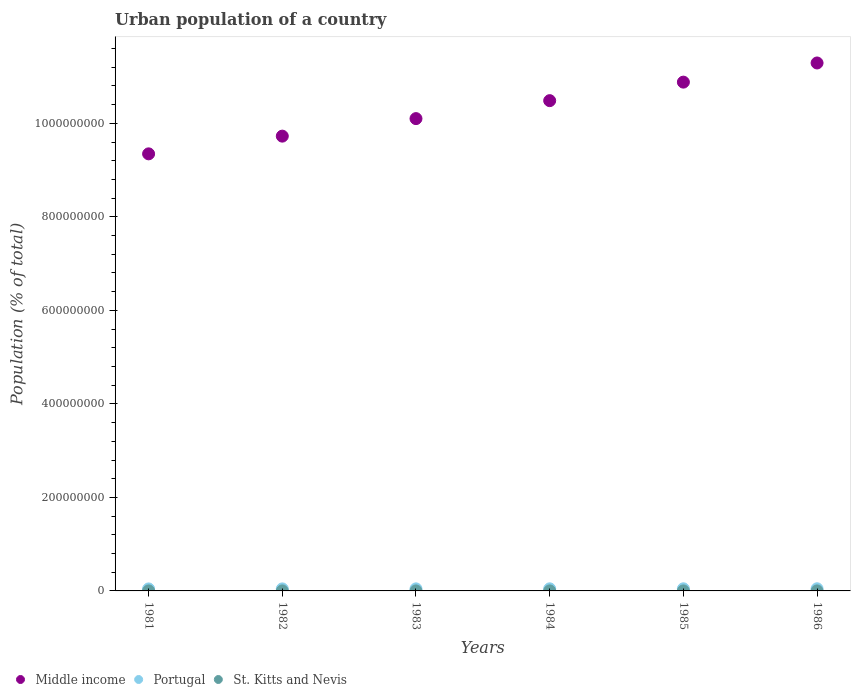What is the urban population in Portugal in 1984?
Give a very brief answer. 4.48e+06. Across all years, what is the maximum urban population in Portugal?
Provide a succinct answer. 4.60e+06. Across all years, what is the minimum urban population in St. Kitts and Nevis?
Offer a terse response. 1.46e+04. What is the total urban population in Middle income in the graph?
Offer a very short reply. 6.18e+09. What is the difference between the urban population in Portugal in 1983 and that in 1986?
Give a very brief answer. -1.90e+05. What is the difference between the urban population in Middle income in 1984 and the urban population in St. Kitts and Nevis in 1982?
Offer a terse response. 1.05e+09. What is the average urban population in St. Kitts and Nevis per year?
Your response must be concise. 1.50e+04. In the year 1984, what is the difference between the urban population in St. Kitts and Nevis and urban population in Middle income?
Your answer should be very brief. -1.05e+09. In how many years, is the urban population in St. Kitts and Nevis greater than 40000000 %?
Your answer should be compact. 0. What is the ratio of the urban population in Portugal in 1983 to that in 1986?
Your answer should be very brief. 0.96. Is the urban population in Portugal in 1985 less than that in 1986?
Give a very brief answer. Yes. What is the difference between the highest and the second highest urban population in Middle income?
Offer a terse response. 4.10e+07. What is the difference between the highest and the lowest urban population in St. Kitts and Nevis?
Offer a terse response. 724. In how many years, is the urban population in Middle income greater than the average urban population in Middle income taken over all years?
Offer a terse response. 3. Does the urban population in Middle income monotonically increase over the years?
Your response must be concise. Yes. Is the urban population in St. Kitts and Nevis strictly greater than the urban population in Middle income over the years?
Provide a short and direct response. No. Is the urban population in Middle income strictly less than the urban population in St. Kitts and Nevis over the years?
Keep it short and to the point. No. How many dotlines are there?
Provide a succinct answer. 3. What is the difference between two consecutive major ticks on the Y-axis?
Keep it short and to the point. 2.00e+08. Does the graph contain grids?
Your answer should be very brief. No. Where does the legend appear in the graph?
Provide a succinct answer. Bottom left. What is the title of the graph?
Provide a succinct answer. Urban population of a country. What is the label or title of the Y-axis?
Your response must be concise. Population (% of total). What is the Population (% of total) in Middle income in 1981?
Your answer should be very brief. 9.35e+08. What is the Population (% of total) in Portugal in 1981?
Offer a terse response. 4.26e+06. What is the Population (% of total) in St. Kitts and Nevis in 1981?
Offer a terse response. 1.54e+04. What is the Population (% of total) in Middle income in 1982?
Keep it short and to the point. 9.73e+08. What is the Population (% of total) of Portugal in 1982?
Make the answer very short. 4.34e+06. What is the Population (% of total) in St. Kitts and Nevis in 1982?
Offer a terse response. 1.52e+04. What is the Population (% of total) of Middle income in 1983?
Give a very brief answer. 1.01e+09. What is the Population (% of total) of Portugal in 1983?
Keep it short and to the point. 4.41e+06. What is the Population (% of total) in St. Kitts and Nevis in 1983?
Offer a very short reply. 1.51e+04. What is the Population (% of total) of Middle income in 1984?
Keep it short and to the point. 1.05e+09. What is the Population (% of total) of Portugal in 1984?
Give a very brief answer. 4.48e+06. What is the Population (% of total) of St. Kitts and Nevis in 1984?
Your response must be concise. 1.50e+04. What is the Population (% of total) in Middle income in 1985?
Give a very brief answer. 1.09e+09. What is the Population (% of total) of Portugal in 1985?
Your response must be concise. 4.54e+06. What is the Population (% of total) in St. Kitts and Nevis in 1985?
Your answer should be compact. 1.48e+04. What is the Population (% of total) of Middle income in 1986?
Provide a short and direct response. 1.13e+09. What is the Population (% of total) in Portugal in 1986?
Offer a very short reply. 4.60e+06. What is the Population (% of total) of St. Kitts and Nevis in 1986?
Your answer should be very brief. 1.46e+04. Across all years, what is the maximum Population (% of total) in Middle income?
Give a very brief answer. 1.13e+09. Across all years, what is the maximum Population (% of total) in Portugal?
Your answer should be very brief. 4.60e+06. Across all years, what is the maximum Population (% of total) of St. Kitts and Nevis?
Your response must be concise. 1.54e+04. Across all years, what is the minimum Population (% of total) in Middle income?
Offer a very short reply. 9.35e+08. Across all years, what is the minimum Population (% of total) of Portugal?
Offer a very short reply. 4.26e+06. Across all years, what is the minimum Population (% of total) of St. Kitts and Nevis?
Your response must be concise. 1.46e+04. What is the total Population (% of total) of Middle income in the graph?
Ensure brevity in your answer.  6.18e+09. What is the total Population (% of total) in Portugal in the graph?
Provide a succinct answer. 2.66e+07. What is the total Population (% of total) in St. Kitts and Nevis in the graph?
Your answer should be compact. 9.01e+04. What is the difference between the Population (% of total) of Middle income in 1981 and that in 1982?
Give a very brief answer. -3.79e+07. What is the difference between the Population (% of total) in Portugal in 1981 and that in 1982?
Offer a terse response. -7.74e+04. What is the difference between the Population (% of total) of St. Kitts and Nevis in 1981 and that in 1982?
Offer a very short reply. 132. What is the difference between the Population (% of total) of Middle income in 1981 and that in 1983?
Provide a short and direct response. -7.53e+07. What is the difference between the Population (% of total) in Portugal in 1981 and that in 1983?
Provide a short and direct response. -1.49e+05. What is the difference between the Population (% of total) in St. Kitts and Nevis in 1981 and that in 1983?
Keep it short and to the point. 266. What is the difference between the Population (% of total) of Middle income in 1981 and that in 1984?
Provide a short and direct response. -1.14e+08. What is the difference between the Population (% of total) in Portugal in 1981 and that in 1984?
Offer a terse response. -2.18e+05. What is the difference between the Population (% of total) in St. Kitts and Nevis in 1981 and that in 1984?
Offer a very short reply. 407. What is the difference between the Population (% of total) of Middle income in 1981 and that in 1985?
Give a very brief answer. -1.53e+08. What is the difference between the Population (% of total) of Portugal in 1981 and that in 1985?
Your answer should be very brief. -2.83e+05. What is the difference between the Population (% of total) of St. Kitts and Nevis in 1981 and that in 1985?
Make the answer very short. 558. What is the difference between the Population (% of total) in Middle income in 1981 and that in 1986?
Your response must be concise. -1.94e+08. What is the difference between the Population (% of total) in Portugal in 1981 and that in 1986?
Offer a terse response. -3.39e+05. What is the difference between the Population (% of total) of St. Kitts and Nevis in 1981 and that in 1986?
Offer a very short reply. 724. What is the difference between the Population (% of total) of Middle income in 1982 and that in 1983?
Give a very brief answer. -3.75e+07. What is the difference between the Population (% of total) of Portugal in 1982 and that in 1983?
Offer a very short reply. -7.18e+04. What is the difference between the Population (% of total) in St. Kitts and Nevis in 1982 and that in 1983?
Offer a terse response. 134. What is the difference between the Population (% of total) in Middle income in 1982 and that in 1984?
Give a very brief answer. -7.59e+07. What is the difference between the Population (% of total) in Portugal in 1982 and that in 1984?
Your answer should be compact. -1.41e+05. What is the difference between the Population (% of total) in St. Kitts and Nevis in 1982 and that in 1984?
Your answer should be very brief. 275. What is the difference between the Population (% of total) in Middle income in 1982 and that in 1985?
Make the answer very short. -1.16e+08. What is the difference between the Population (% of total) in Portugal in 1982 and that in 1985?
Offer a terse response. -2.05e+05. What is the difference between the Population (% of total) in St. Kitts and Nevis in 1982 and that in 1985?
Your answer should be compact. 426. What is the difference between the Population (% of total) in Middle income in 1982 and that in 1986?
Offer a terse response. -1.56e+08. What is the difference between the Population (% of total) of Portugal in 1982 and that in 1986?
Your answer should be compact. -2.62e+05. What is the difference between the Population (% of total) in St. Kitts and Nevis in 1982 and that in 1986?
Provide a short and direct response. 592. What is the difference between the Population (% of total) of Middle income in 1983 and that in 1984?
Make the answer very short. -3.84e+07. What is the difference between the Population (% of total) in Portugal in 1983 and that in 1984?
Provide a succinct answer. -6.90e+04. What is the difference between the Population (% of total) in St. Kitts and Nevis in 1983 and that in 1984?
Provide a succinct answer. 141. What is the difference between the Population (% of total) of Middle income in 1983 and that in 1985?
Give a very brief answer. -7.80e+07. What is the difference between the Population (% of total) in Portugal in 1983 and that in 1985?
Offer a terse response. -1.33e+05. What is the difference between the Population (% of total) of St. Kitts and Nevis in 1983 and that in 1985?
Provide a short and direct response. 292. What is the difference between the Population (% of total) in Middle income in 1983 and that in 1986?
Give a very brief answer. -1.19e+08. What is the difference between the Population (% of total) in Portugal in 1983 and that in 1986?
Provide a short and direct response. -1.90e+05. What is the difference between the Population (% of total) of St. Kitts and Nevis in 1983 and that in 1986?
Your answer should be compact. 458. What is the difference between the Population (% of total) in Middle income in 1984 and that in 1985?
Your answer should be very brief. -3.96e+07. What is the difference between the Population (% of total) of Portugal in 1984 and that in 1985?
Your answer should be compact. -6.45e+04. What is the difference between the Population (% of total) of St. Kitts and Nevis in 1984 and that in 1985?
Keep it short and to the point. 151. What is the difference between the Population (% of total) of Middle income in 1984 and that in 1986?
Your answer should be compact. -8.06e+07. What is the difference between the Population (% of total) of Portugal in 1984 and that in 1986?
Provide a short and direct response. -1.21e+05. What is the difference between the Population (% of total) of St. Kitts and Nevis in 1984 and that in 1986?
Your response must be concise. 317. What is the difference between the Population (% of total) in Middle income in 1985 and that in 1986?
Your answer should be very brief. -4.10e+07. What is the difference between the Population (% of total) in Portugal in 1985 and that in 1986?
Keep it short and to the point. -5.65e+04. What is the difference between the Population (% of total) in St. Kitts and Nevis in 1985 and that in 1986?
Your answer should be compact. 166. What is the difference between the Population (% of total) of Middle income in 1981 and the Population (% of total) of Portugal in 1982?
Keep it short and to the point. 9.30e+08. What is the difference between the Population (% of total) in Middle income in 1981 and the Population (% of total) in St. Kitts and Nevis in 1982?
Make the answer very short. 9.35e+08. What is the difference between the Population (% of total) of Portugal in 1981 and the Population (% of total) of St. Kitts and Nevis in 1982?
Offer a terse response. 4.24e+06. What is the difference between the Population (% of total) of Middle income in 1981 and the Population (% of total) of Portugal in 1983?
Your answer should be compact. 9.30e+08. What is the difference between the Population (% of total) of Middle income in 1981 and the Population (% of total) of St. Kitts and Nevis in 1983?
Offer a terse response. 9.35e+08. What is the difference between the Population (% of total) of Portugal in 1981 and the Population (% of total) of St. Kitts and Nevis in 1983?
Your answer should be compact. 4.24e+06. What is the difference between the Population (% of total) in Middle income in 1981 and the Population (% of total) in Portugal in 1984?
Offer a terse response. 9.30e+08. What is the difference between the Population (% of total) in Middle income in 1981 and the Population (% of total) in St. Kitts and Nevis in 1984?
Offer a terse response. 9.35e+08. What is the difference between the Population (% of total) of Portugal in 1981 and the Population (% of total) of St. Kitts and Nevis in 1984?
Offer a very short reply. 4.24e+06. What is the difference between the Population (% of total) of Middle income in 1981 and the Population (% of total) of Portugal in 1985?
Your answer should be compact. 9.30e+08. What is the difference between the Population (% of total) in Middle income in 1981 and the Population (% of total) in St. Kitts and Nevis in 1985?
Your response must be concise. 9.35e+08. What is the difference between the Population (% of total) of Portugal in 1981 and the Population (% of total) of St. Kitts and Nevis in 1985?
Your response must be concise. 4.24e+06. What is the difference between the Population (% of total) of Middle income in 1981 and the Population (% of total) of Portugal in 1986?
Ensure brevity in your answer.  9.30e+08. What is the difference between the Population (% of total) of Middle income in 1981 and the Population (% of total) of St. Kitts and Nevis in 1986?
Offer a terse response. 9.35e+08. What is the difference between the Population (% of total) of Portugal in 1981 and the Population (% of total) of St. Kitts and Nevis in 1986?
Give a very brief answer. 4.24e+06. What is the difference between the Population (% of total) in Middle income in 1982 and the Population (% of total) in Portugal in 1983?
Offer a very short reply. 9.68e+08. What is the difference between the Population (% of total) of Middle income in 1982 and the Population (% of total) of St. Kitts and Nevis in 1983?
Offer a terse response. 9.73e+08. What is the difference between the Population (% of total) of Portugal in 1982 and the Population (% of total) of St. Kitts and Nevis in 1983?
Your answer should be compact. 4.32e+06. What is the difference between the Population (% of total) of Middle income in 1982 and the Population (% of total) of Portugal in 1984?
Give a very brief answer. 9.68e+08. What is the difference between the Population (% of total) in Middle income in 1982 and the Population (% of total) in St. Kitts and Nevis in 1984?
Your response must be concise. 9.73e+08. What is the difference between the Population (% of total) in Portugal in 1982 and the Population (% of total) in St. Kitts and Nevis in 1984?
Provide a short and direct response. 4.32e+06. What is the difference between the Population (% of total) in Middle income in 1982 and the Population (% of total) in Portugal in 1985?
Your answer should be compact. 9.68e+08. What is the difference between the Population (% of total) in Middle income in 1982 and the Population (% of total) in St. Kitts and Nevis in 1985?
Your answer should be compact. 9.73e+08. What is the difference between the Population (% of total) of Portugal in 1982 and the Population (% of total) of St. Kitts and Nevis in 1985?
Make the answer very short. 4.32e+06. What is the difference between the Population (% of total) of Middle income in 1982 and the Population (% of total) of Portugal in 1986?
Offer a very short reply. 9.68e+08. What is the difference between the Population (% of total) of Middle income in 1982 and the Population (% of total) of St. Kitts and Nevis in 1986?
Your answer should be compact. 9.73e+08. What is the difference between the Population (% of total) in Portugal in 1982 and the Population (% of total) in St. Kitts and Nevis in 1986?
Your answer should be compact. 4.32e+06. What is the difference between the Population (% of total) in Middle income in 1983 and the Population (% of total) in Portugal in 1984?
Provide a succinct answer. 1.01e+09. What is the difference between the Population (% of total) of Middle income in 1983 and the Population (% of total) of St. Kitts and Nevis in 1984?
Your answer should be compact. 1.01e+09. What is the difference between the Population (% of total) of Portugal in 1983 and the Population (% of total) of St. Kitts and Nevis in 1984?
Keep it short and to the point. 4.39e+06. What is the difference between the Population (% of total) in Middle income in 1983 and the Population (% of total) in Portugal in 1985?
Offer a terse response. 1.01e+09. What is the difference between the Population (% of total) in Middle income in 1983 and the Population (% of total) in St. Kitts and Nevis in 1985?
Offer a terse response. 1.01e+09. What is the difference between the Population (% of total) in Portugal in 1983 and the Population (% of total) in St. Kitts and Nevis in 1985?
Ensure brevity in your answer.  4.39e+06. What is the difference between the Population (% of total) of Middle income in 1983 and the Population (% of total) of Portugal in 1986?
Provide a short and direct response. 1.01e+09. What is the difference between the Population (% of total) in Middle income in 1983 and the Population (% of total) in St. Kitts and Nevis in 1986?
Your answer should be very brief. 1.01e+09. What is the difference between the Population (% of total) in Portugal in 1983 and the Population (% of total) in St. Kitts and Nevis in 1986?
Provide a short and direct response. 4.39e+06. What is the difference between the Population (% of total) of Middle income in 1984 and the Population (% of total) of Portugal in 1985?
Keep it short and to the point. 1.04e+09. What is the difference between the Population (% of total) in Middle income in 1984 and the Population (% of total) in St. Kitts and Nevis in 1985?
Your answer should be very brief. 1.05e+09. What is the difference between the Population (% of total) of Portugal in 1984 and the Population (% of total) of St. Kitts and Nevis in 1985?
Provide a succinct answer. 4.46e+06. What is the difference between the Population (% of total) of Middle income in 1984 and the Population (% of total) of Portugal in 1986?
Give a very brief answer. 1.04e+09. What is the difference between the Population (% of total) of Middle income in 1984 and the Population (% of total) of St. Kitts and Nevis in 1986?
Your answer should be very brief. 1.05e+09. What is the difference between the Population (% of total) of Portugal in 1984 and the Population (% of total) of St. Kitts and Nevis in 1986?
Offer a very short reply. 4.46e+06. What is the difference between the Population (% of total) of Middle income in 1985 and the Population (% of total) of Portugal in 1986?
Your response must be concise. 1.08e+09. What is the difference between the Population (% of total) of Middle income in 1985 and the Population (% of total) of St. Kitts and Nevis in 1986?
Give a very brief answer. 1.09e+09. What is the difference between the Population (% of total) of Portugal in 1985 and the Population (% of total) of St. Kitts and Nevis in 1986?
Provide a short and direct response. 4.53e+06. What is the average Population (% of total) of Middle income per year?
Provide a succinct answer. 1.03e+09. What is the average Population (% of total) in Portugal per year?
Your answer should be very brief. 4.44e+06. What is the average Population (% of total) in St. Kitts and Nevis per year?
Provide a succinct answer. 1.50e+04. In the year 1981, what is the difference between the Population (% of total) of Middle income and Population (% of total) of Portugal?
Ensure brevity in your answer.  9.31e+08. In the year 1981, what is the difference between the Population (% of total) in Middle income and Population (% of total) in St. Kitts and Nevis?
Keep it short and to the point. 9.35e+08. In the year 1981, what is the difference between the Population (% of total) in Portugal and Population (% of total) in St. Kitts and Nevis?
Your response must be concise. 4.24e+06. In the year 1982, what is the difference between the Population (% of total) in Middle income and Population (% of total) in Portugal?
Keep it short and to the point. 9.68e+08. In the year 1982, what is the difference between the Population (% of total) of Middle income and Population (% of total) of St. Kitts and Nevis?
Make the answer very short. 9.73e+08. In the year 1982, what is the difference between the Population (% of total) of Portugal and Population (% of total) of St. Kitts and Nevis?
Provide a short and direct response. 4.32e+06. In the year 1983, what is the difference between the Population (% of total) in Middle income and Population (% of total) in Portugal?
Give a very brief answer. 1.01e+09. In the year 1983, what is the difference between the Population (% of total) of Middle income and Population (% of total) of St. Kitts and Nevis?
Ensure brevity in your answer.  1.01e+09. In the year 1983, what is the difference between the Population (% of total) in Portugal and Population (% of total) in St. Kitts and Nevis?
Give a very brief answer. 4.39e+06. In the year 1984, what is the difference between the Population (% of total) in Middle income and Population (% of total) in Portugal?
Offer a very short reply. 1.04e+09. In the year 1984, what is the difference between the Population (% of total) in Middle income and Population (% of total) in St. Kitts and Nevis?
Ensure brevity in your answer.  1.05e+09. In the year 1984, what is the difference between the Population (% of total) of Portugal and Population (% of total) of St. Kitts and Nevis?
Your response must be concise. 4.46e+06. In the year 1985, what is the difference between the Population (% of total) of Middle income and Population (% of total) of Portugal?
Offer a very short reply. 1.08e+09. In the year 1985, what is the difference between the Population (% of total) in Middle income and Population (% of total) in St. Kitts and Nevis?
Provide a succinct answer. 1.09e+09. In the year 1985, what is the difference between the Population (% of total) in Portugal and Population (% of total) in St. Kitts and Nevis?
Offer a very short reply. 4.53e+06. In the year 1986, what is the difference between the Population (% of total) in Middle income and Population (% of total) in Portugal?
Provide a succinct answer. 1.12e+09. In the year 1986, what is the difference between the Population (% of total) of Middle income and Population (% of total) of St. Kitts and Nevis?
Your response must be concise. 1.13e+09. In the year 1986, what is the difference between the Population (% of total) in Portugal and Population (% of total) in St. Kitts and Nevis?
Your answer should be very brief. 4.58e+06. What is the ratio of the Population (% of total) of Middle income in 1981 to that in 1982?
Ensure brevity in your answer.  0.96. What is the ratio of the Population (% of total) of Portugal in 1981 to that in 1982?
Give a very brief answer. 0.98. What is the ratio of the Population (% of total) of St. Kitts and Nevis in 1981 to that in 1982?
Offer a very short reply. 1.01. What is the ratio of the Population (% of total) in Middle income in 1981 to that in 1983?
Ensure brevity in your answer.  0.93. What is the ratio of the Population (% of total) in Portugal in 1981 to that in 1983?
Offer a terse response. 0.97. What is the ratio of the Population (% of total) in St. Kitts and Nevis in 1981 to that in 1983?
Offer a terse response. 1.02. What is the ratio of the Population (% of total) in Middle income in 1981 to that in 1984?
Your answer should be very brief. 0.89. What is the ratio of the Population (% of total) in Portugal in 1981 to that in 1984?
Provide a succinct answer. 0.95. What is the ratio of the Population (% of total) in St. Kitts and Nevis in 1981 to that in 1984?
Give a very brief answer. 1.03. What is the ratio of the Population (% of total) of Middle income in 1981 to that in 1985?
Offer a terse response. 0.86. What is the ratio of the Population (% of total) in Portugal in 1981 to that in 1985?
Give a very brief answer. 0.94. What is the ratio of the Population (% of total) of St. Kitts and Nevis in 1981 to that in 1985?
Your answer should be very brief. 1.04. What is the ratio of the Population (% of total) of Middle income in 1981 to that in 1986?
Keep it short and to the point. 0.83. What is the ratio of the Population (% of total) of Portugal in 1981 to that in 1986?
Make the answer very short. 0.93. What is the ratio of the Population (% of total) in St. Kitts and Nevis in 1981 to that in 1986?
Ensure brevity in your answer.  1.05. What is the ratio of the Population (% of total) in Middle income in 1982 to that in 1983?
Offer a terse response. 0.96. What is the ratio of the Population (% of total) of Portugal in 1982 to that in 1983?
Your answer should be compact. 0.98. What is the ratio of the Population (% of total) in St. Kitts and Nevis in 1982 to that in 1983?
Provide a succinct answer. 1.01. What is the ratio of the Population (% of total) in Middle income in 1982 to that in 1984?
Provide a short and direct response. 0.93. What is the ratio of the Population (% of total) of Portugal in 1982 to that in 1984?
Make the answer very short. 0.97. What is the ratio of the Population (% of total) of St. Kitts and Nevis in 1982 to that in 1984?
Offer a very short reply. 1.02. What is the ratio of the Population (% of total) in Middle income in 1982 to that in 1985?
Your response must be concise. 0.89. What is the ratio of the Population (% of total) of Portugal in 1982 to that in 1985?
Provide a short and direct response. 0.95. What is the ratio of the Population (% of total) of St. Kitts and Nevis in 1982 to that in 1985?
Your response must be concise. 1.03. What is the ratio of the Population (% of total) in Middle income in 1982 to that in 1986?
Your answer should be very brief. 0.86. What is the ratio of the Population (% of total) of Portugal in 1982 to that in 1986?
Offer a terse response. 0.94. What is the ratio of the Population (% of total) of St. Kitts and Nevis in 1982 to that in 1986?
Provide a succinct answer. 1.04. What is the ratio of the Population (% of total) in Middle income in 1983 to that in 1984?
Provide a succinct answer. 0.96. What is the ratio of the Population (% of total) in Portugal in 1983 to that in 1984?
Provide a short and direct response. 0.98. What is the ratio of the Population (% of total) in St. Kitts and Nevis in 1983 to that in 1984?
Your response must be concise. 1.01. What is the ratio of the Population (% of total) in Middle income in 1983 to that in 1985?
Your answer should be compact. 0.93. What is the ratio of the Population (% of total) in Portugal in 1983 to that in 1985?
Give a very brief answer. 0.97. What is the ratio of the Population (% of total) of St. Kitts and Nevis in 1983 to that in 1985?
Ensure brevity in your answer.  1.02. What is the ratio of the Population (% of total) of Middle income in 1983 to that in 1986?
Your response must be concise. 0.89. What is the ratio of the Population (% of total) in Portugal in 1983 to that in 1986?
Make the answer very short. 0.96. What is the ratio of the Population (% of total) in St. Kitts and Nevis in 1983 to that in 1986?
Provide a short and direct response. 1.03. What is the ratio of the Population (% of total) in Middle income in 1984 to that in 1985?
Your answer should be compact. 0.96. What is the ratio of the Population (% of total) of Portugal in 1984 to that in 1985?
Offer a terse response. 0.99. What is the ratio of the Population (% of total) of St. Kitts and Nevis in 1984 to that in 1985?
Give a very brief answer. 1.01. What is the ratio of the Population (% of total) of Portugal in 1984 to that in 1986?
Your answer should be very brief. 0.97. What is the ratio of the Population (% of total) of St. Kitts and Nevis in 1984 to that in 1986?
Offer a very short reply. 1.02. What is the ratio of the Population (% of total) of Middle income in 1985 to that in 1986?
Provide a succinct answer. 0.96. What is the ratio of the Population (% of total) in Portugal in 1985 to that in 1986?
Your answer should be very brief. 0.99. What is the ratio of the Population (% of total) in St. Kitts and Nevis in 1985 to that in 1986?
Provide a short and direct response. 1.01. What is the difference between the highest and the second highest Population (% of total) in Middle income?
Make the answer very short. 4.10e+07. What is the difference between the highest and the second highest Population (% of total) in Portugal?
Ensure brevity in your answer.  5.65e+04. What is the difference between the highest and the second highest Population (% of total) in St. Kitts and Nevis?
Ensure brevity in your answer.  132. What is the difference between the highest and the lowest Population (% of total) of Middle income?
Offer a terse response. 1.94e+08. What is the difference between the highest and the lowest Population (% of total) in Portugal?
Your response must be concise. 3.39e+05. What is the difference between the highest and the lowest Population (% of total) in St. Kitts and Nevis?
Ensure brevity in your answer.  724. 